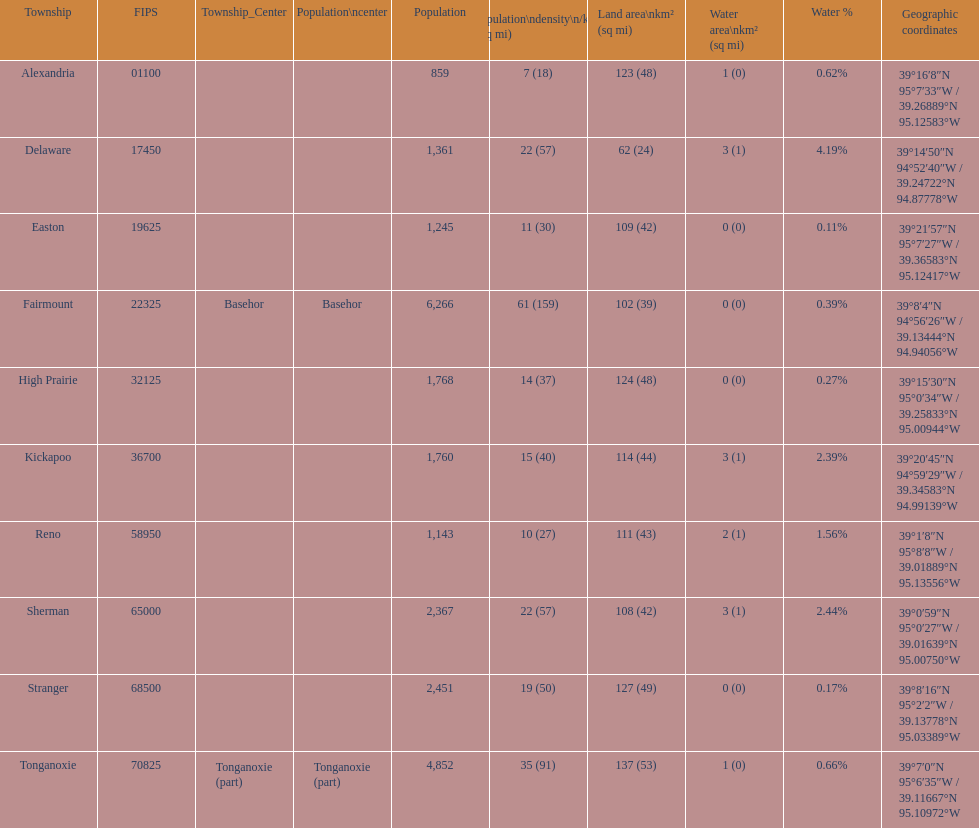What township has the largest population? Fairmount. 